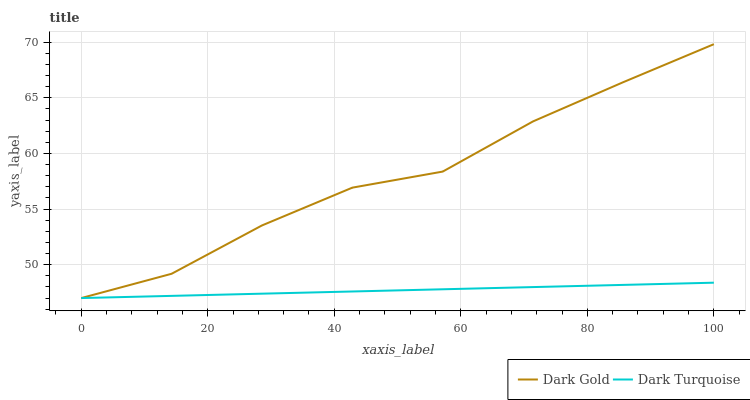Does Dark Turquoise have the minimum area under the curve?
Answer yes or no. Yes. Does Dark Gold have the maximum area under the curve?
Answer yes or no. Yes. Does Dark Gold have the minimum area under the curve?
Answer yes or no. No. Is Dark Turquoise the smoothest?
Answer yes or no. Yes. Is Dark Gold the roughest?
Answer yes or no. Yes. Is Dark Gold the smoothest?
Answer yes or no. No. Does Dark Gold have the highest value?
Answer yes or no. Yes. Does Dark Turquoise intersect Dark Gold?
Answer yes or no. Yes. Is Dark Turquoise less than Dark Gold?
Answer yes or no. No. Is Dark Turquoise greater than Dark Gold?
Answer yes or no. No. 